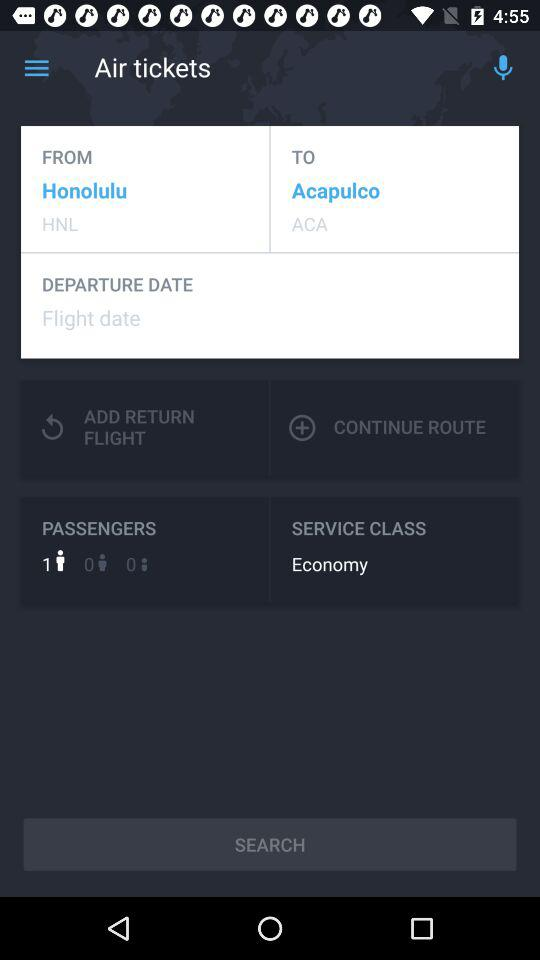What is the status of the "SERVICE CLASS"? The status is "Economy". 